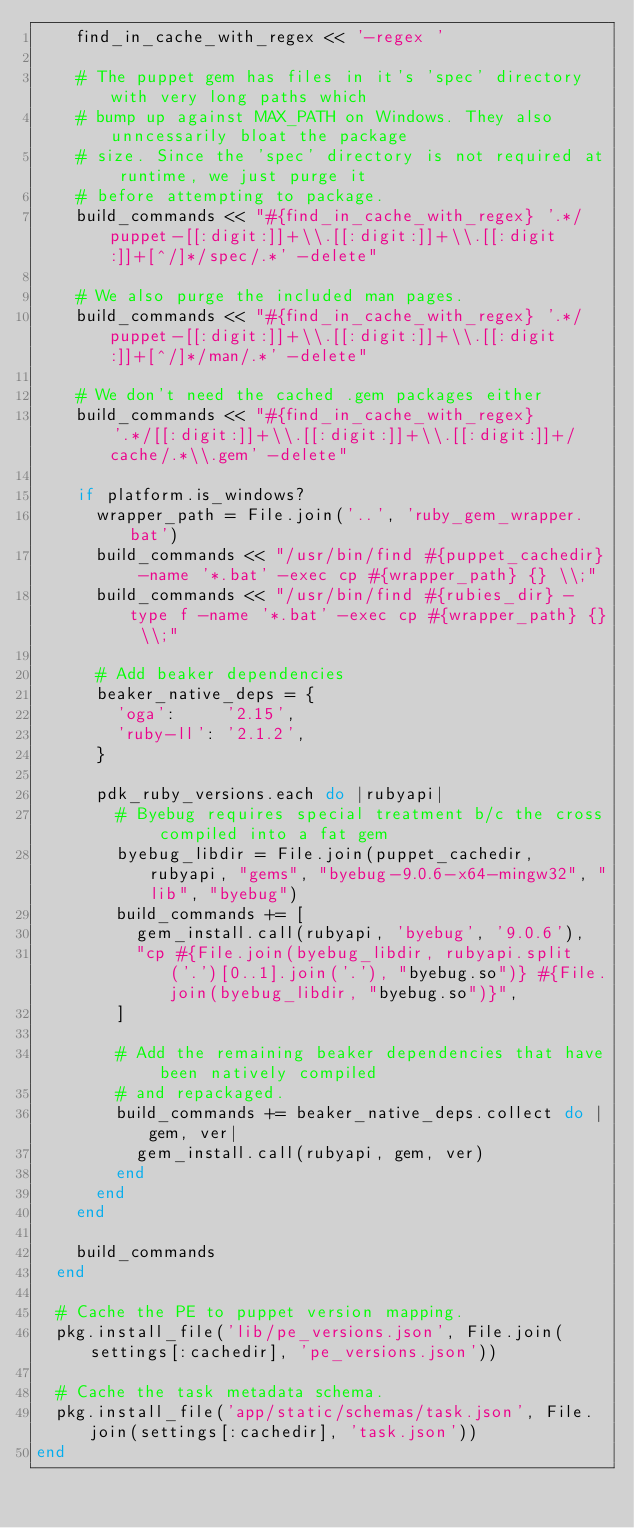Convert code to text. <code><loc_0><loc_0><loc_500><loc_500><_Ruby_>    find_in_cache_with_regex << '-regex '

    # The puppet gem has files in it's 'spec' directory with very long paths which
    # bump up against MAX_PATH on Windows. They also unncessarily bloat the package
    # size. Since the 'spec' directory is not required at runtime, we just purge it
    # before attempting to package.
    build_commands << "#{find_in_cache_with_regex} '.*/puppet-[[:digit:]]+\\.[[:digit:]]+\\.[[:digit:]]+[^/]*/spec/.*' -delete"

    # We also purge the included man pages.
    build_commands << "#{find_in_cache_with_regex} '.*/puppet-[[:digit:]]+\\.[[:digit:]]+\\.[[:digit:]]+[^/]*/man/.*' -delete"

    # We don't need the cached .gem packages either
    build_commands << "#{find_in_cache_with_regex} '.*/[[:digit:]]+\\.[[:digit:]]+\\.[[:digit:]]+/cache/.*\\.gem' -delete"

    if platform.is_windows?
      wrapper_path = File.join('..', 'ruby_gem_wrapper.bat')
      build_commands << "/usr/bin/find #{puppet_cachedir} -name '*.bat' -exec cp #{wrapper_path} {} \\;"
      build_commands << "/usr/bin/find #{rubies_dir} -type f -name '*.bat' -exec cp #{wrapper_path} {} \\;"

      # Add beaker dependencies
      beaker_native_deps = {
        'oga':     '2.15',
        'ruby-ll': '2.1.2',
      }

      pdk_ruby_versions.each do |rubyapi|
        # Byebug requires special treatment b/c the cross compiled into a fat gem
        byebug_libdir = File.join(puppet_cachedir, rubyapi, "gems", "byebug-9.0.6-x64-mingw32", "lib", "byebug")
        build_commands += [
          gem_install.call(rubyapi, 'byebug', '9.0.6'),
          "cp #{File.join(byebug_libdir, rubyapi.split('.')[0..1].join('.'), "byebug.so")} #{File.join(byebug_libdir, "byebug.so")}",
        ]

        # Add the remaining beaker dependencies that have been natively compiled
        # and repackaged.
        build_commands += beaker_native_deps.collect do |gem, ver|
          gem_install.call(rubyapi, gem, ver)
        end
      end
    end

    build_commands
  end

  # Cache the PE to puppet version mapping.
  pkg.install_file('lib/pe_versions.json', File.join(settings[:cachedir], 'pe_versions.json'))

  # Cache the task metadata schema.
  pkg.install_file('app/static/schemas/task.json', File.join(settings[:cachedir], 'task.json'))
end
</code> 